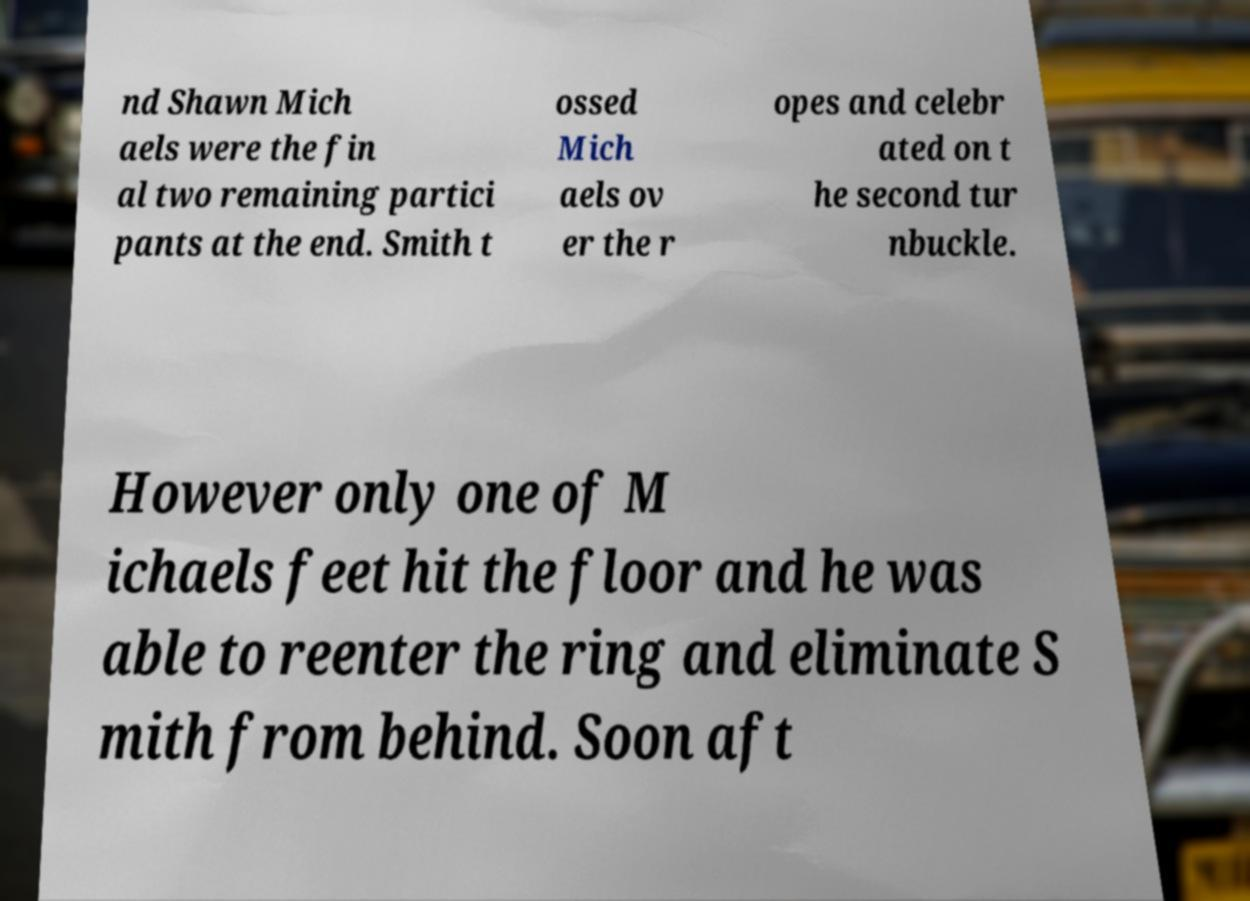For documentation purposes, I need the text within this image transcribed. Could you provide that? nd Shawn Mich aels were the fin al two remaining partici pants at the end. Smith t ossed Mich aels ov er the r opes and celebr ated on t he second tur nbuckle. However only one of M ichaels feet hit the floor and he was able to reenter the ring and eliminate S mith from behind. Soon aft 